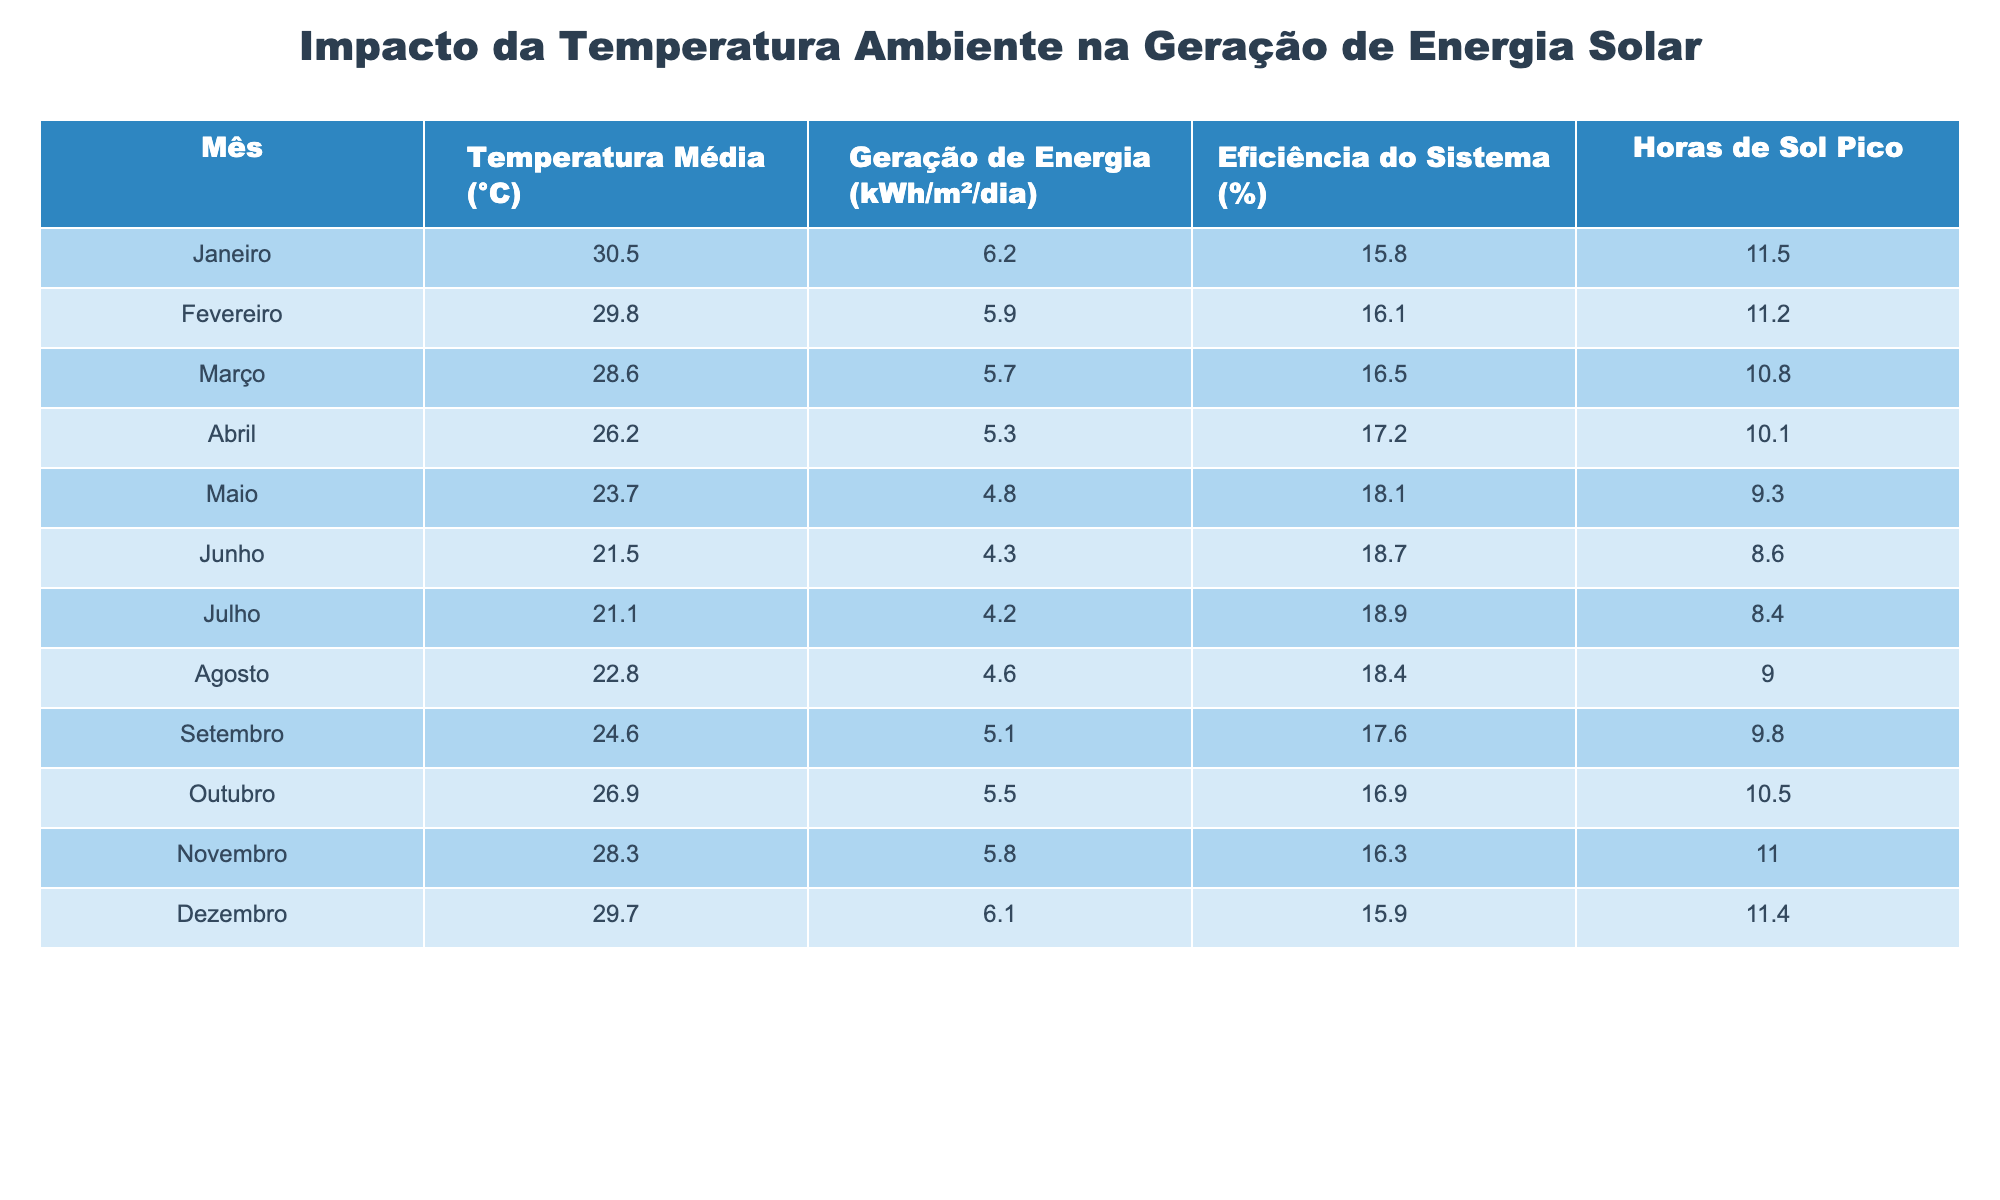Qual é a temperatura média em Julho? A tabela indica que a temperatura média em Julho é de 21.1 °C.
Answer: 21.1 °C Qual foi a geração de energia em Dezembro? A tabela mostra que a geração de energia em Dezembro foi de 6.1 kWh/m²/dia.
Answer: 6.1 kWh/m²/dia Qual é o mês com a maior eficiência do sistema? A maior eficiência do sistema é de 18.9% e ocorre em Julho.
Answer: Julho Qual foi a média de horas de sol pico nos meses de Março e Abril? A média de horas de sol pico em Março (10.8) e Abril (10.1) é calculada como (10.8 + 10.1) / 2 = 10.45.
Answer: 10.45 A temperatura média em Setembro é maior que a de Junho? A tabela mostra que a temperatura média em Setembro (24.6 °C) é maior que a de Junho (21.5 °C), portanto a afirmação é verdadeira.
Answer: Sim Qual mês teve a menor geração de energia? A menor geração de energia foi em Maio com 4.8 kWh/m²/dia.
Answer: Maio Qual é a diferença de geração de energia entre Janeiro e Maio? A geração de energia em Janeiro é 6.2 kWh/m²/dia e em Maio é 4.8 kWh/m²/dia; a diferença é 6.2 - 4.8 = 1.4 kWh/m²/dia.
Answer: 1.4 kWh/m²/dia Em qual mês a eficiência do sistema foi acima de 18%? Os meses em que a eficiência do sistema foi acima de 18% são Maio, Junho, Julho e Agosto.
Answer: Maio, Junho, Julho, Agosto Qual é a média da temperatura média ao longo do ano? A média da temperatura média é calculada somando todas as temperaturas e dividindo por 12, resultando em (30.5 + 29.8 + 28.6 + 26.2 + 23.7 + 21.5 + 21.1 + 22.8 + 24.6 + 26.9 + 28.3 + 29.7) / 12 = 25.5 °C.
Answer: 25.5 °C Qual mês teve a maior variação entre temperatura e geração de energia? A variação é maior em Junho, onde a temperatura é 21.5 °C e a geração é 4.3 kWh/m²/dia. Comparando com outros meses, essa variação é maior.
Answer: Junho 